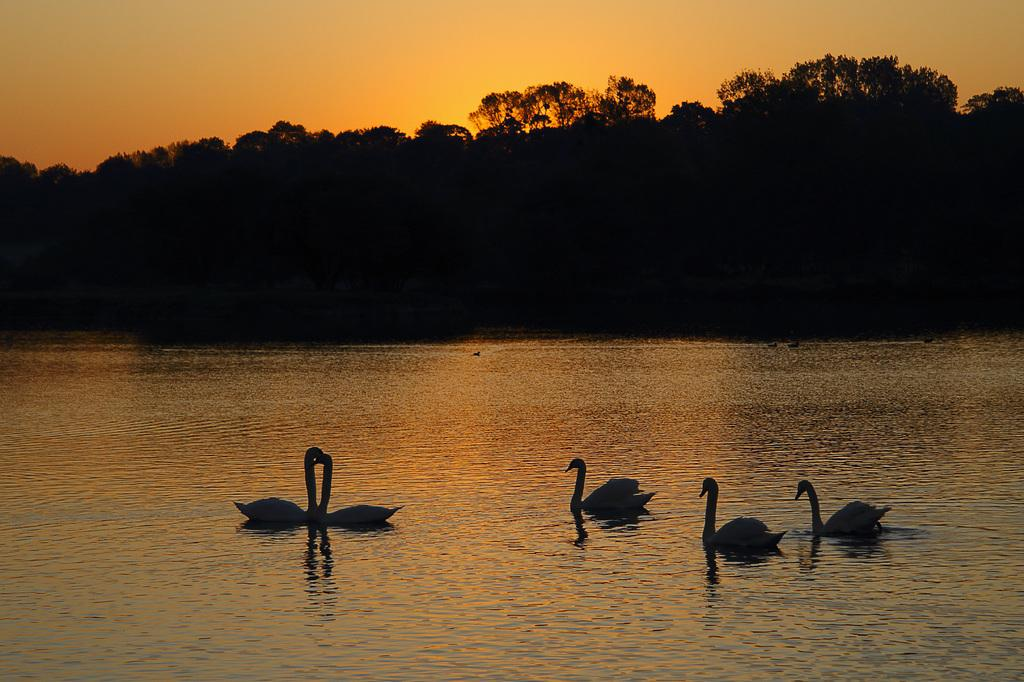What is in the front of the image? There is water in the front of the image. What can be seen in the water? There are swans in the water. What is visible in the background of the image? There are trees in the background of the image. What type of leaf can be seen floating on the water in the image? There is no leaf visible in the image; it only features water and swans. How does the friction between the swans and water affect their movement in the image? The image does not provide information about the friction between the swans and water, so it cannot be determined from the image. 